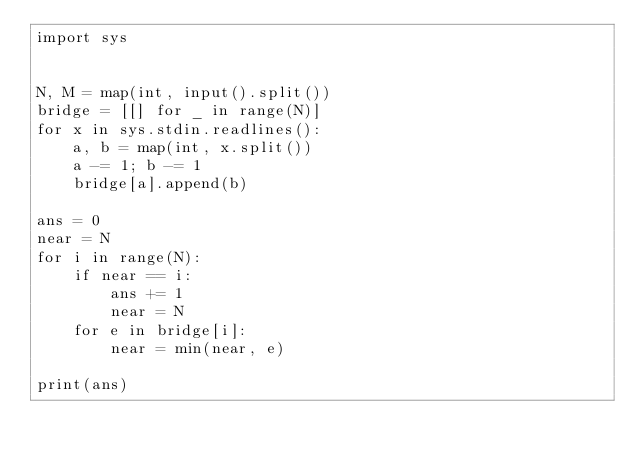Convert code to text. <code><loc_0><loc_0><loc_500><loc_500><_Python_>import sys


N, M = map(int, input().split())
bridge = [[] for _ in range(N)]
for x in sys.stdin.readlines():
    a, b = map(int, x.split())
    a -= 1; b -= 1
    bridge[a].append(b)

ans = 0
near = N
for i in range(N):
    if near == i:
        ans += 1
        near = N
    for e in bridge[i]:
        near = min(near, e)

print(ans)
</code> 